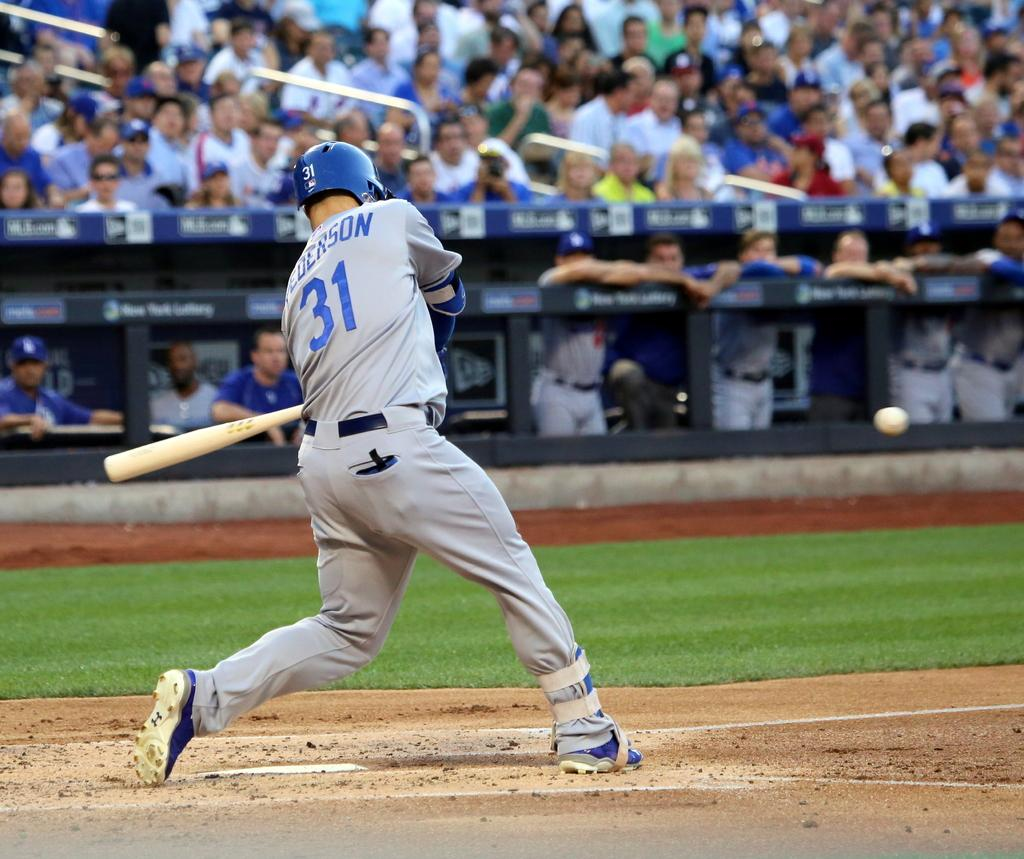<image>
Present a compact description of the photo's key features. A batter has the number 31 in blue on his shirt 